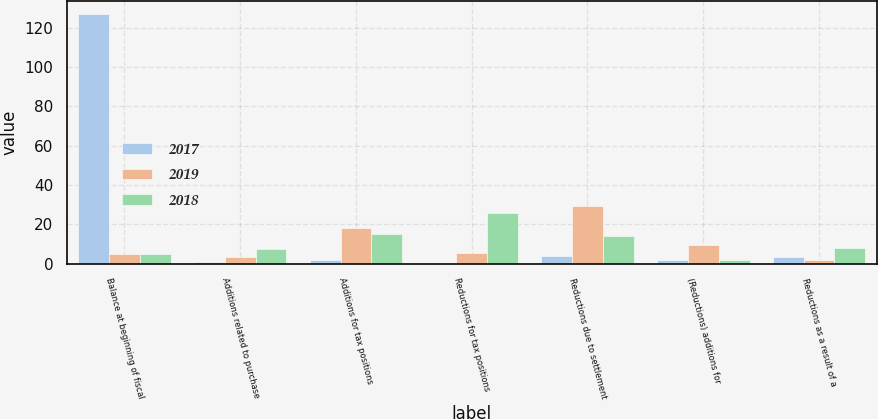Convert chart. <chart><loc_0><loc_0><loc_500><loc_500><stacked_bar_chart><ecel><fcel>Balance at beginning of fiscal<fcel>Additions related to purchase<fcel>Additions for tax positions<fcel>Reductions for tax positions<fcel>Reductions due to settlement<fcel>(Reductions) additions for<fcel>Reductions as a result of a<nl><fcel>2017<fcel>127.1<fcel>1<fcel>1.8<fcel>0.5<fcel>4<fcel>1.7<fcel>3.2<nl><fcel>2019<fcel>5.15<fcel>3.4<fcel>18<fcel>5.3<fcel>29.4<fcel>9.6<fcel>2<nl><fcel>2018<fcel>5.15<fcel>7.7<fcel>15.2<fcel>25.6<fcel>14.1<fcel>2<fcel>8.1<nl></chart> 